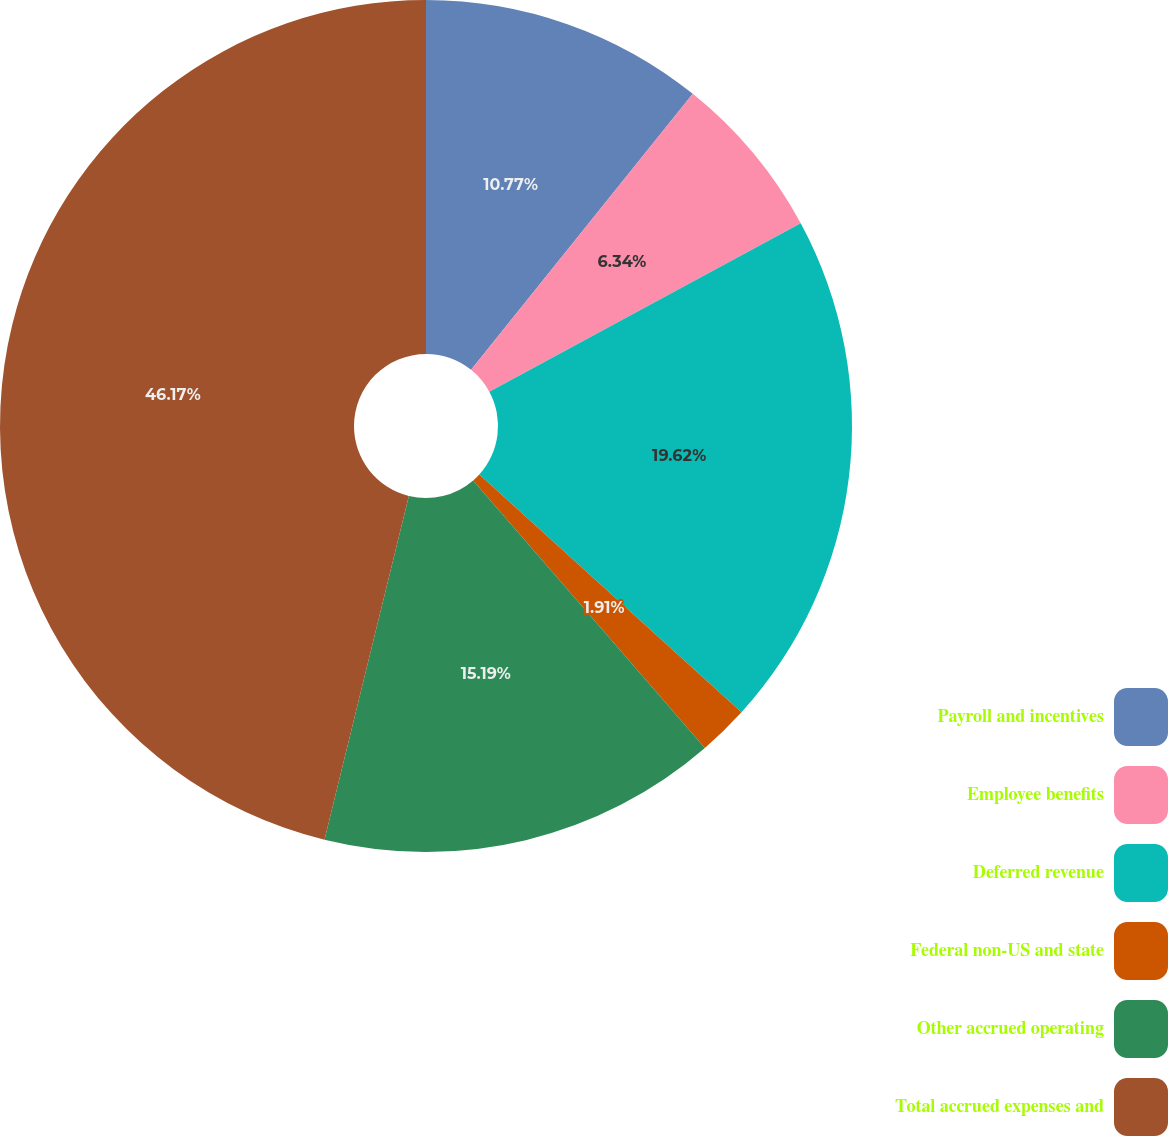Convert chart to OTSL. <chart><loc_0><loc_0><loc_500><loc_500><pie_chart><fcel>Payroll and incentives<fcel>Employee benefits<fcel>Deferred revenue<fcel>Federal non-US and state<fcel>Other accrued operating<fcel>Total accrued expenses and<nl><fcel>10.77%<fcel>6.34%<fcel>19.62%<fcel>1.91%<fcel>15.19%<fcel>46.17%<nl></chart> 